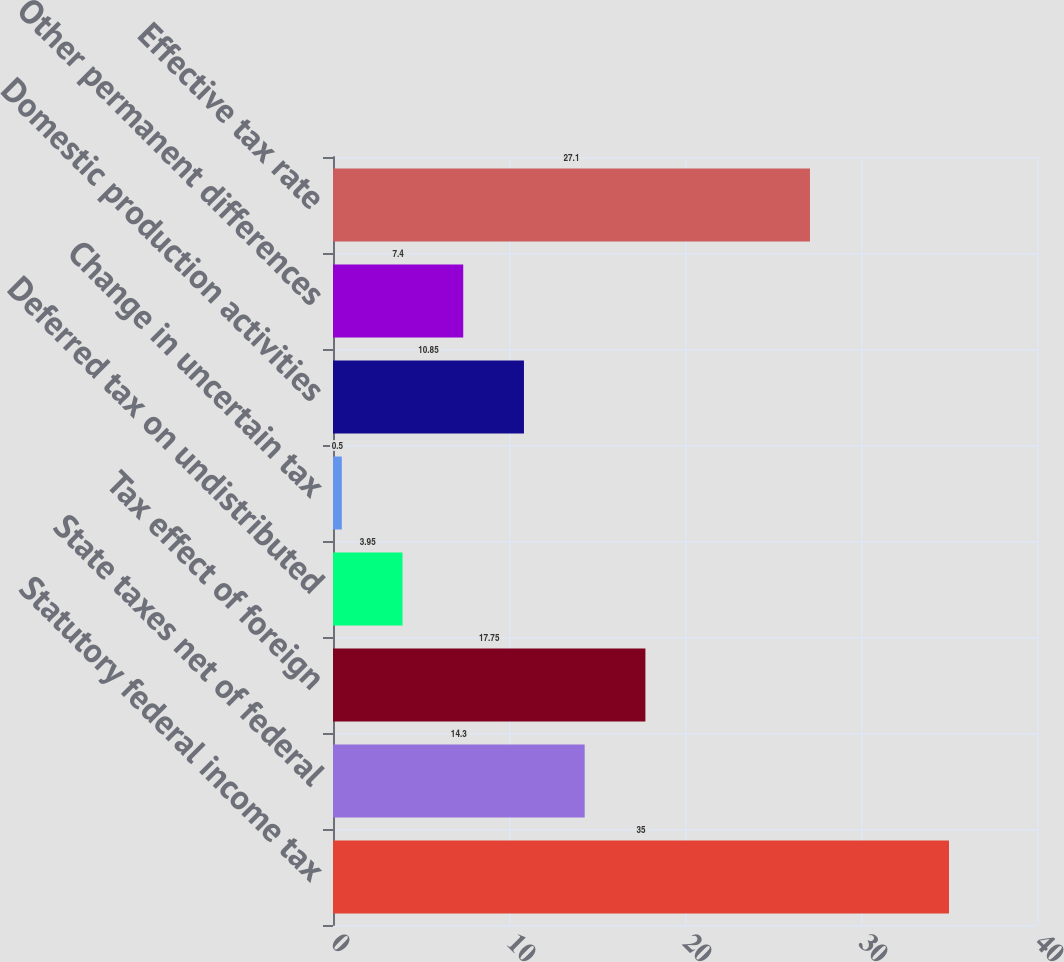Convert chart to OTSL. <chart><loc_0><loc_0><loc_500><loc_500><bar_chart><fcel>Statutory federal income tax<fcel>State taxes net of federal<fcel>Tax effect of foreign<fcel>Deferred tax on undistributed<fcel>Change in uncertain tax<fcel>Domestic production activities<fcel>Other permanent differences<fcel>Effective tax rate<nl><fcel>35<fcel>14.3<fcel>17.75<fcel>3.95<fcel>0.5<fcel>10.85<fcel>7.4<fcel>27.1<nl></chart> 